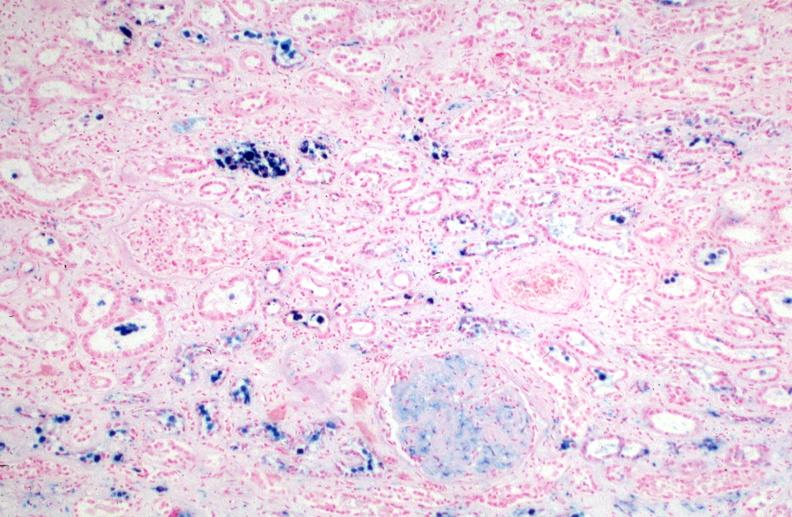what does this image show?
Answer the question using a single word or phrase. Kidney 